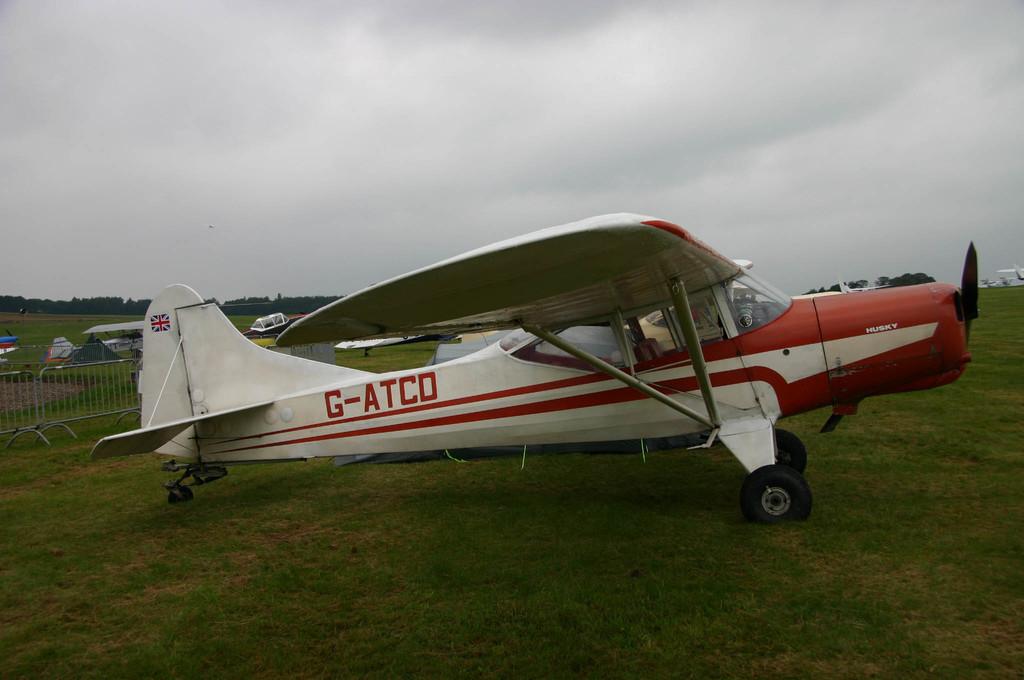What is the name of this plane?
Provide a short and direct response. G-atco. What is the plane's call sign?
Give a very brief answer. G-atco. 